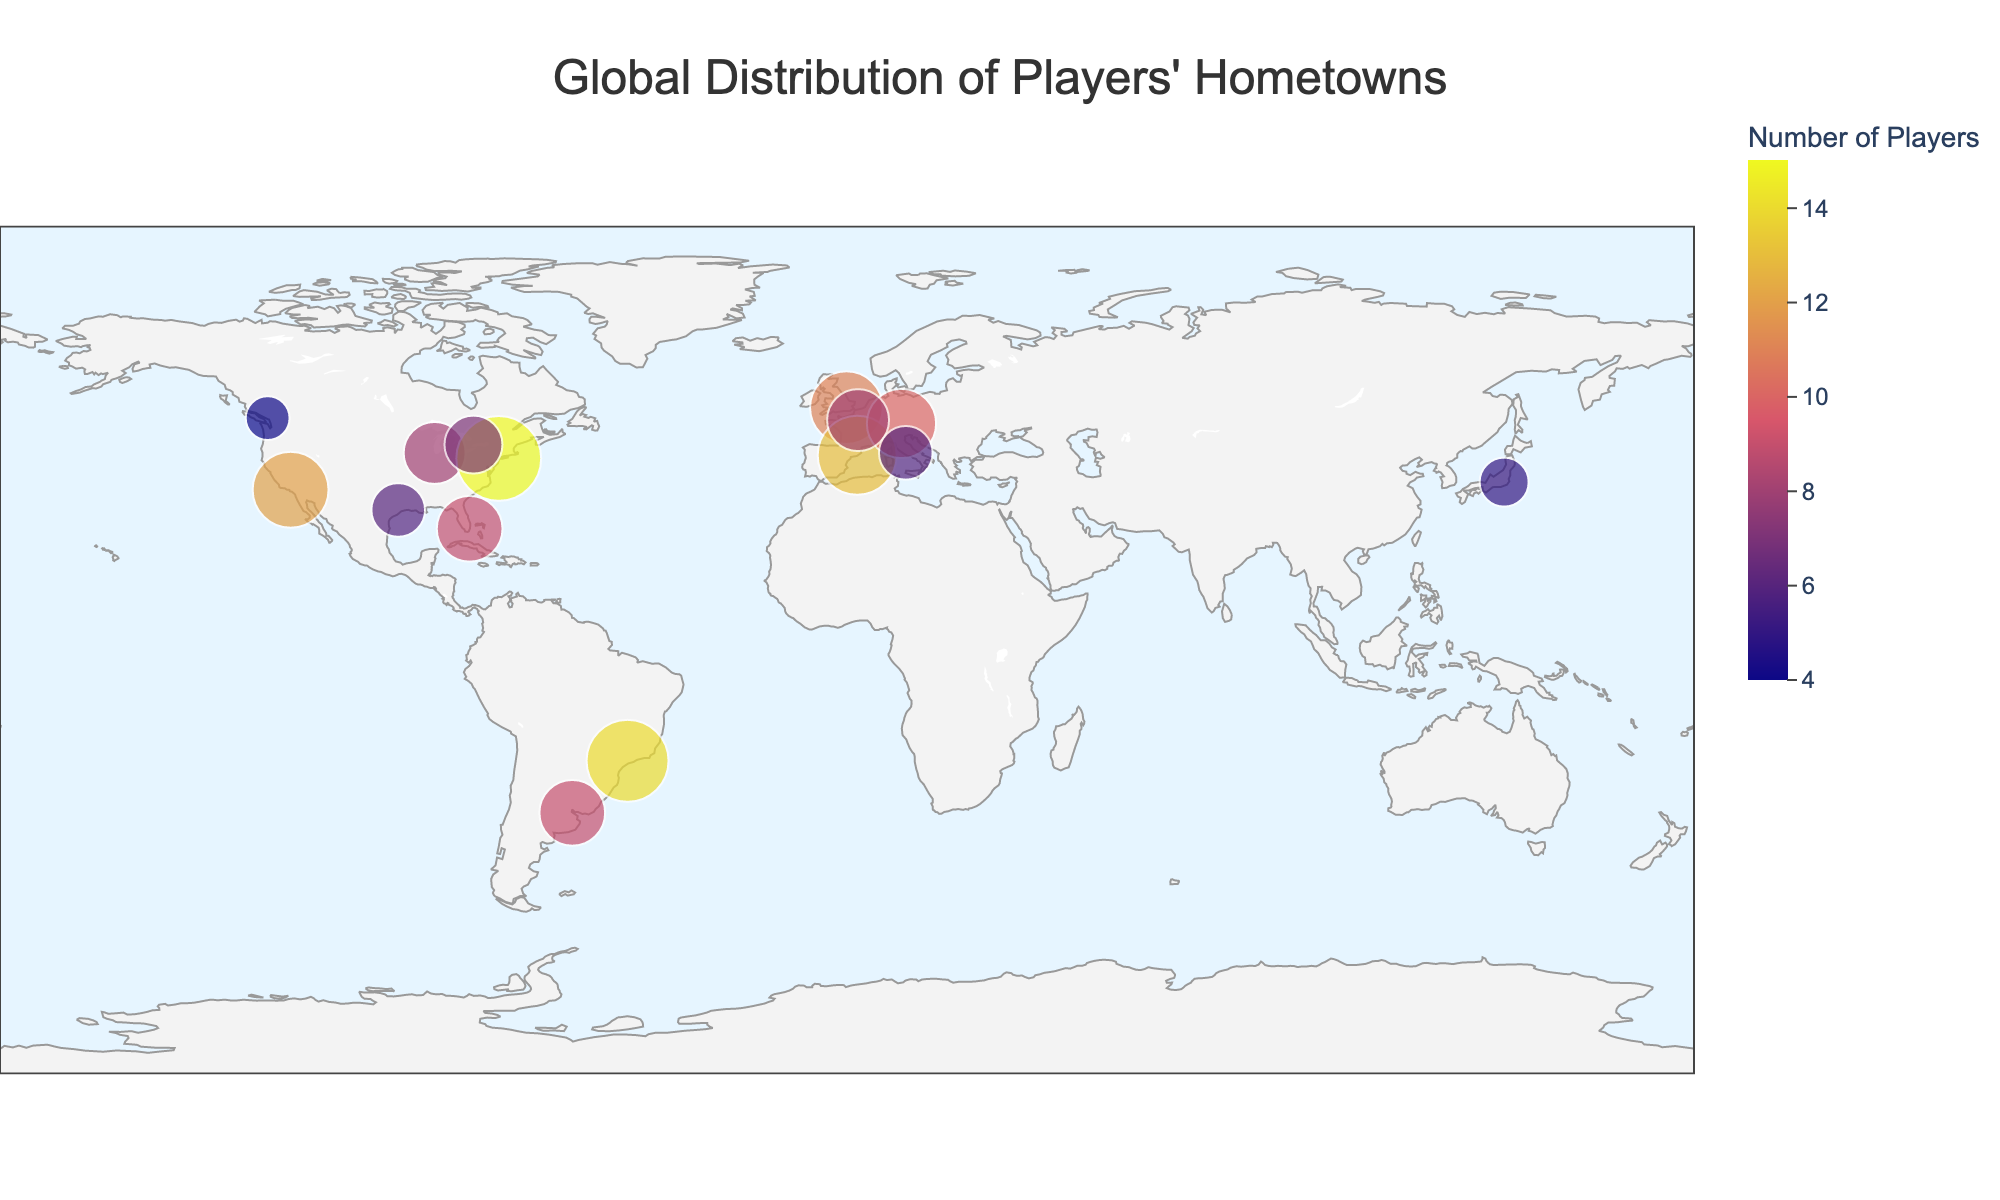What city has the highest number of players? The size of the marker for each city represents the number of players. By identifying the largest marker size, we can see that the city with the highest number of players is New York City with 15 players.
Answer: New York City Which countries have more than one city listed in the plot? By checking the country names associated with the city labels, we can see that the United States and Canada both have more than one city listed: United States (Los Angeles, Chicago, New York City, Houston, Miami) and Canada (Toronto, Vancouver).
Answer: United States, Canada What is the total number of players in European cities? Adding the number of players from the European cities: London (11), Barcelona (13), Munich (10), Paris (8), and Rome (6), the total is 11 + 13 + 10 + 8 + 6 = 48.
Answer: 48 How does the number of players in São Paulo compare to the number of players in Barcelona? By examining the player counts, São Paulo has 14 players and Barcelona has 13 players. So, São Paulo has one more player than Barcelona.
Answer: São Paulo has one more player Which city in Asia has the most players? The two cities in Asia are Tokyo (5 players) and by examining these, we can confirm that there is only one Asian city listed. Thus, Tokyo has the most players in Asia.
Answer: Tokyo What can you infer about the geographic distribution of players' hometowns across continents? By observing the scatter geo plot, we see that players' hometowns are spread across multiple continents including North America, Europe, South America, and Asia. There is a noticeable concentration of players in North American and European cities.
Answer: Players are distributed across several continents, with concentrations in North America and Europe 